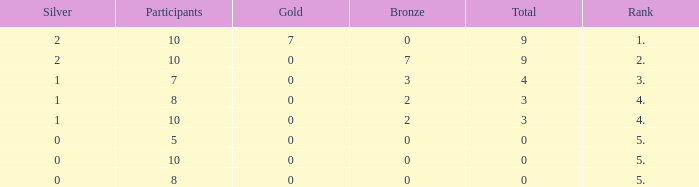What is listed as the highest Participants that also have a Rank of 5, and Silver that's smaller than 0? None. 